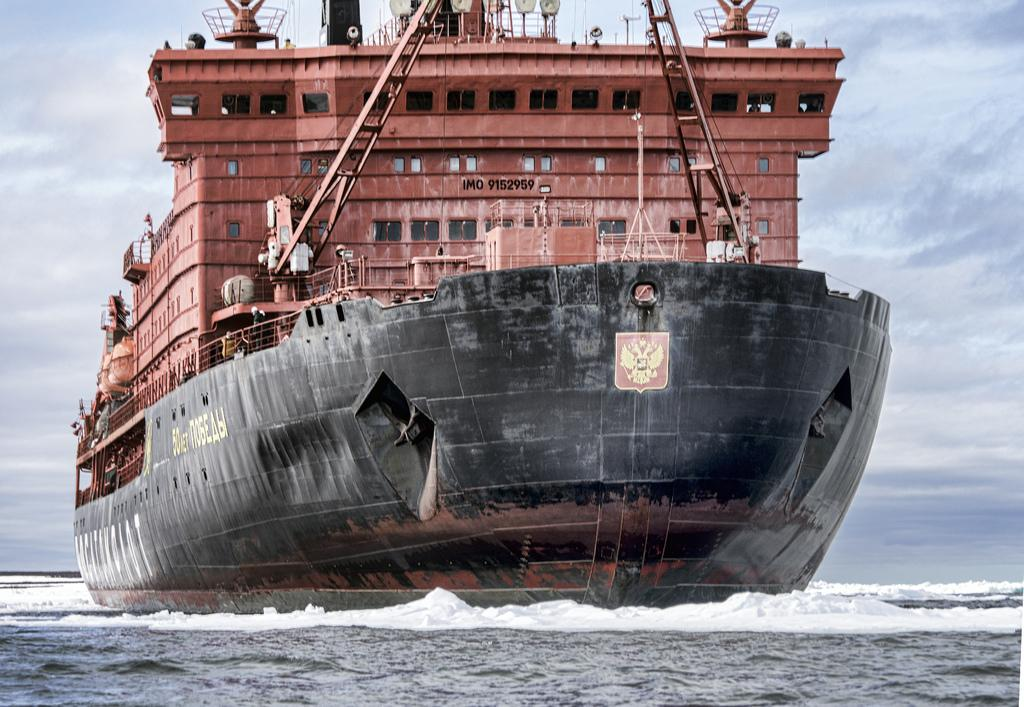What is the main subject of the image? There is a ship in the image. What is the ship doing in the image? The ship is sailing on a sea. What can be seen in the background of the image? There is a cloudy sky in the background of the image. What type of toy is being used to measure the distance between the ship and the shore in the image? There is no toy or measurement activity present in the image. 